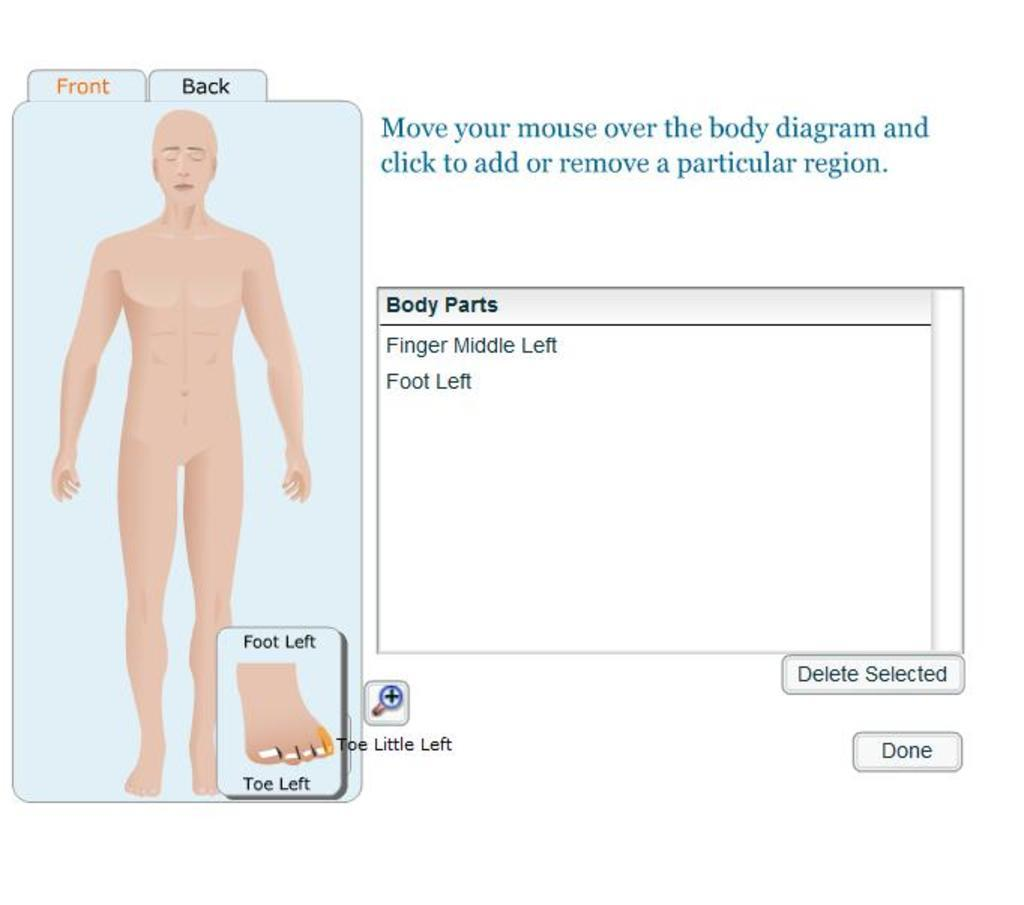What is depicted on the left side of the image? There is a picture of a human body on the left side of the image. What can be found on the right side of the image? There is text on the right side of the image. Can you hear the son coughing in the image? There is no son or any sound present in the image, as it is a static picture. What type of vase is placed on the left side of the image? There is no vase present in the image; it features a picture of a human body and text. 